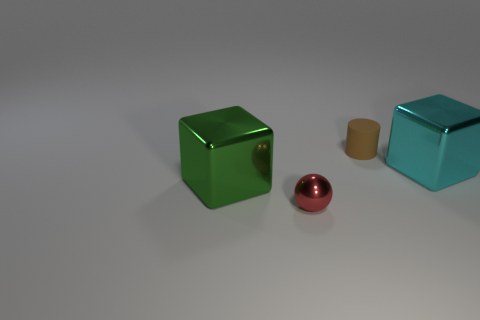Add 2 red cylinders. How many objects exist? 6 Subtract all cylinders. How many objects are left? 3 Subtract 0 gray cylinders. How many objects are left? 4 Subtract all brown blocks. Subtract all green spheres. How many blocks are left? 2 Subtract all small red shiny things. Subtract all big brown cylinders. How many objects are left? 3 Add 2 cyan objects. How many cyan objects are left? 3 Add 3 large objects. How many large objects exist? 5 